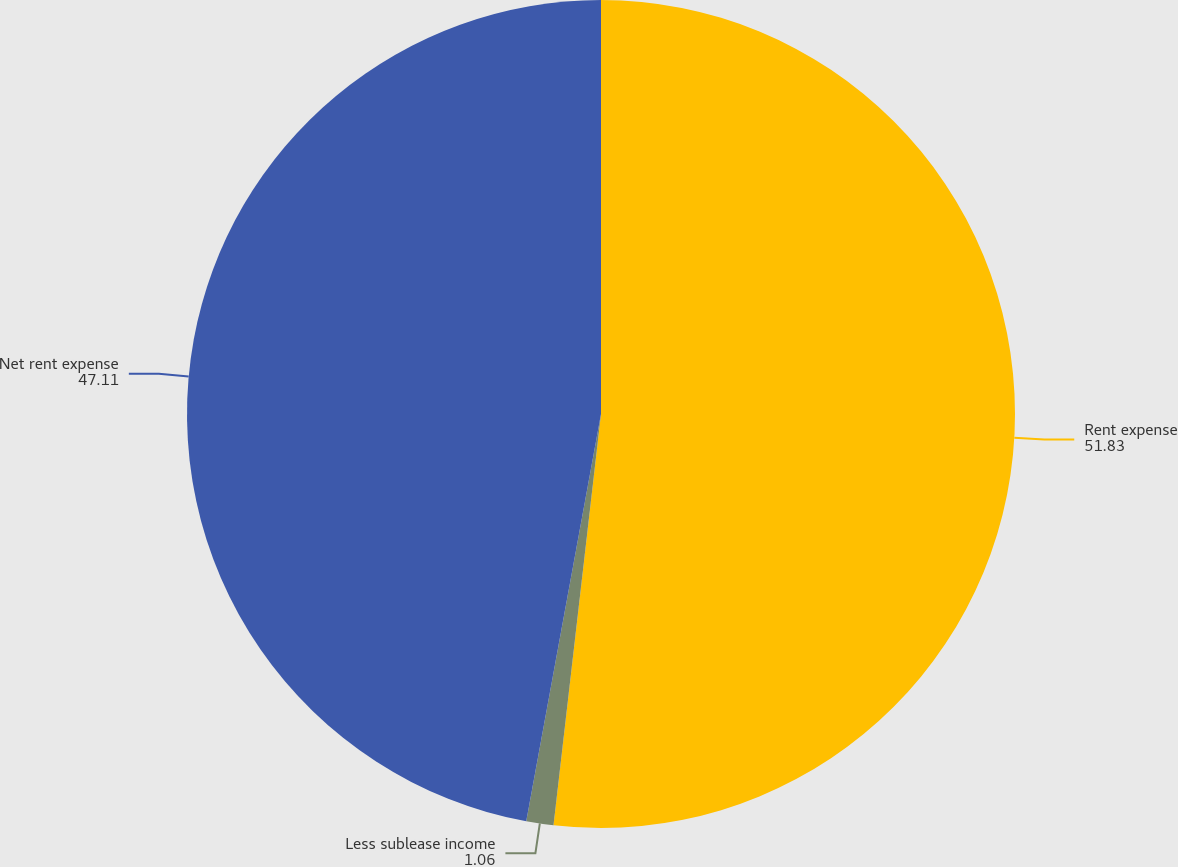<chart> <loc_0><loc_0><loc_500><loc_500><pie_chart><fcel>Rent expense<fcel>Less sublease income<fcel>Net rent expense<nl><fcel>51.83%<fcel>1.06%<fcel>47.11%<nl></chart> 